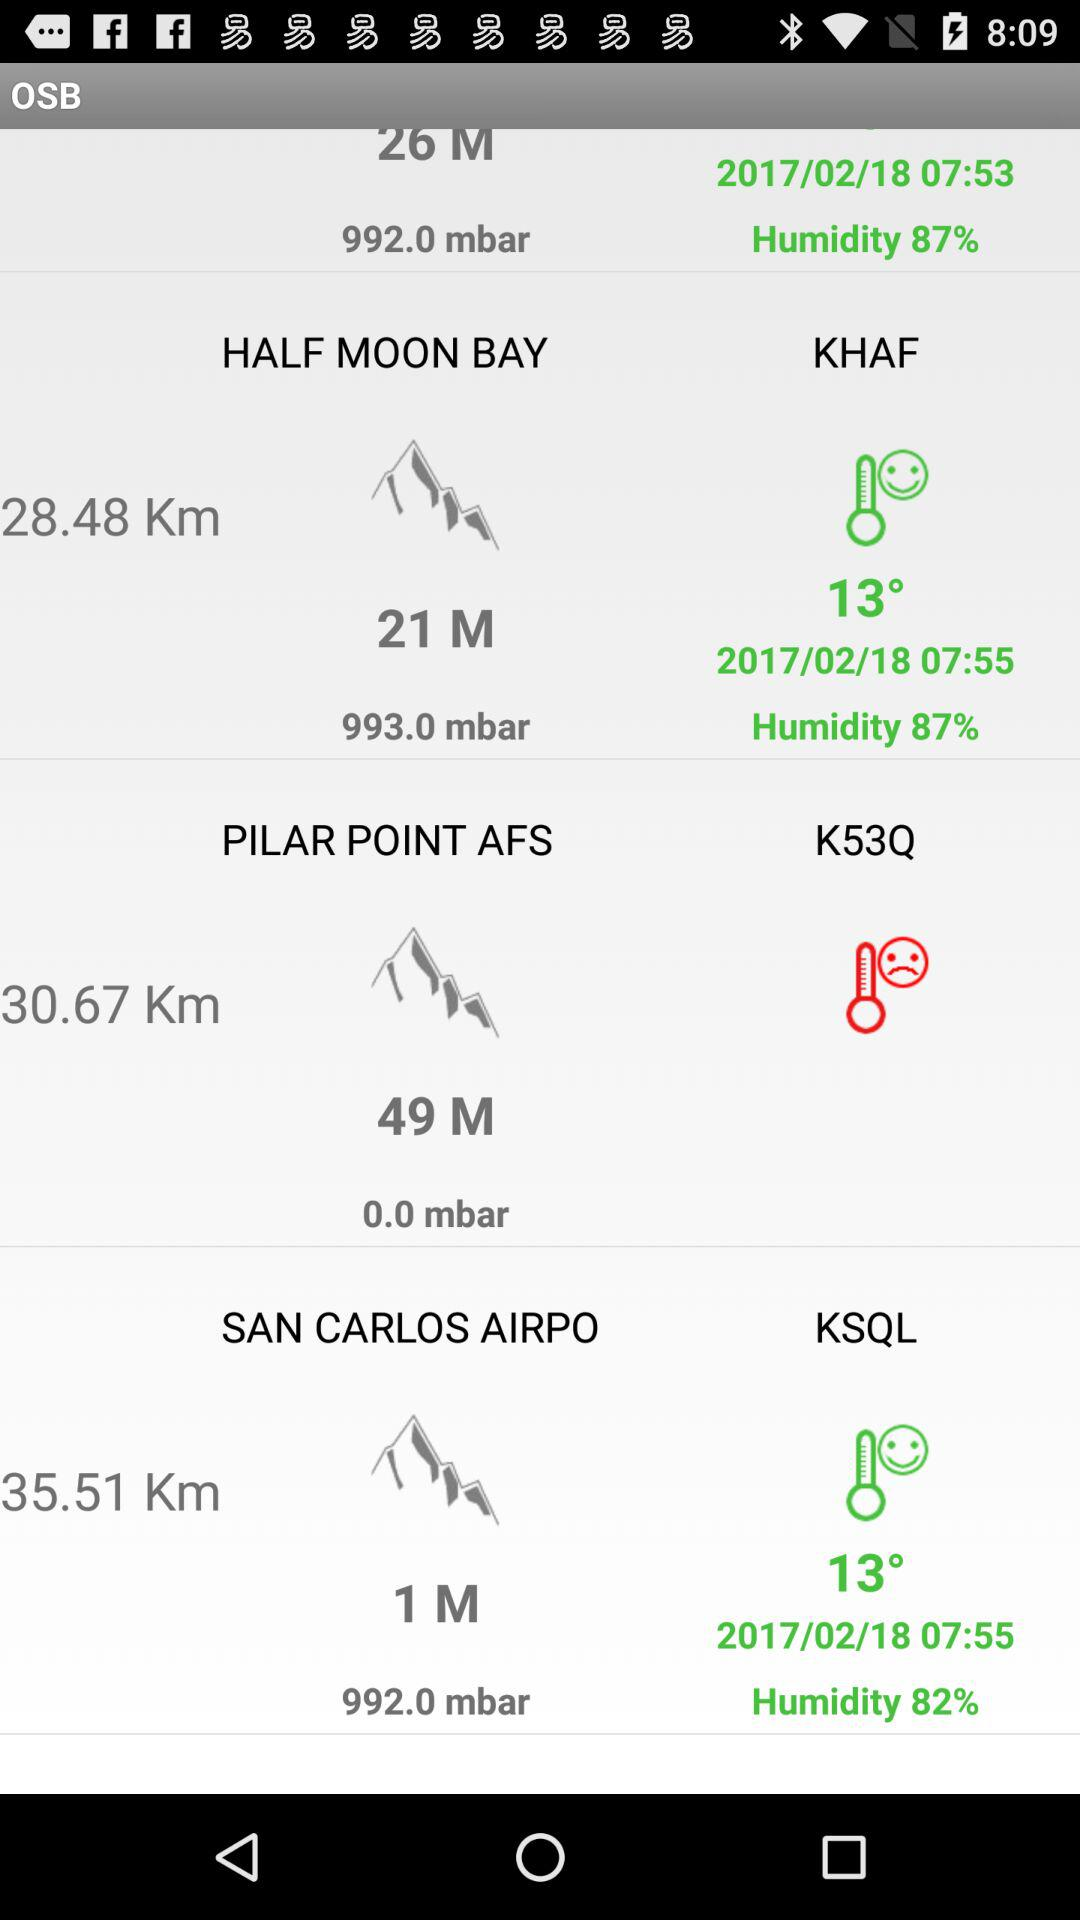What is the temperature of pilarmpoint afs?
When the provided information is insufficient, respond with <no answer>. <no answer> 